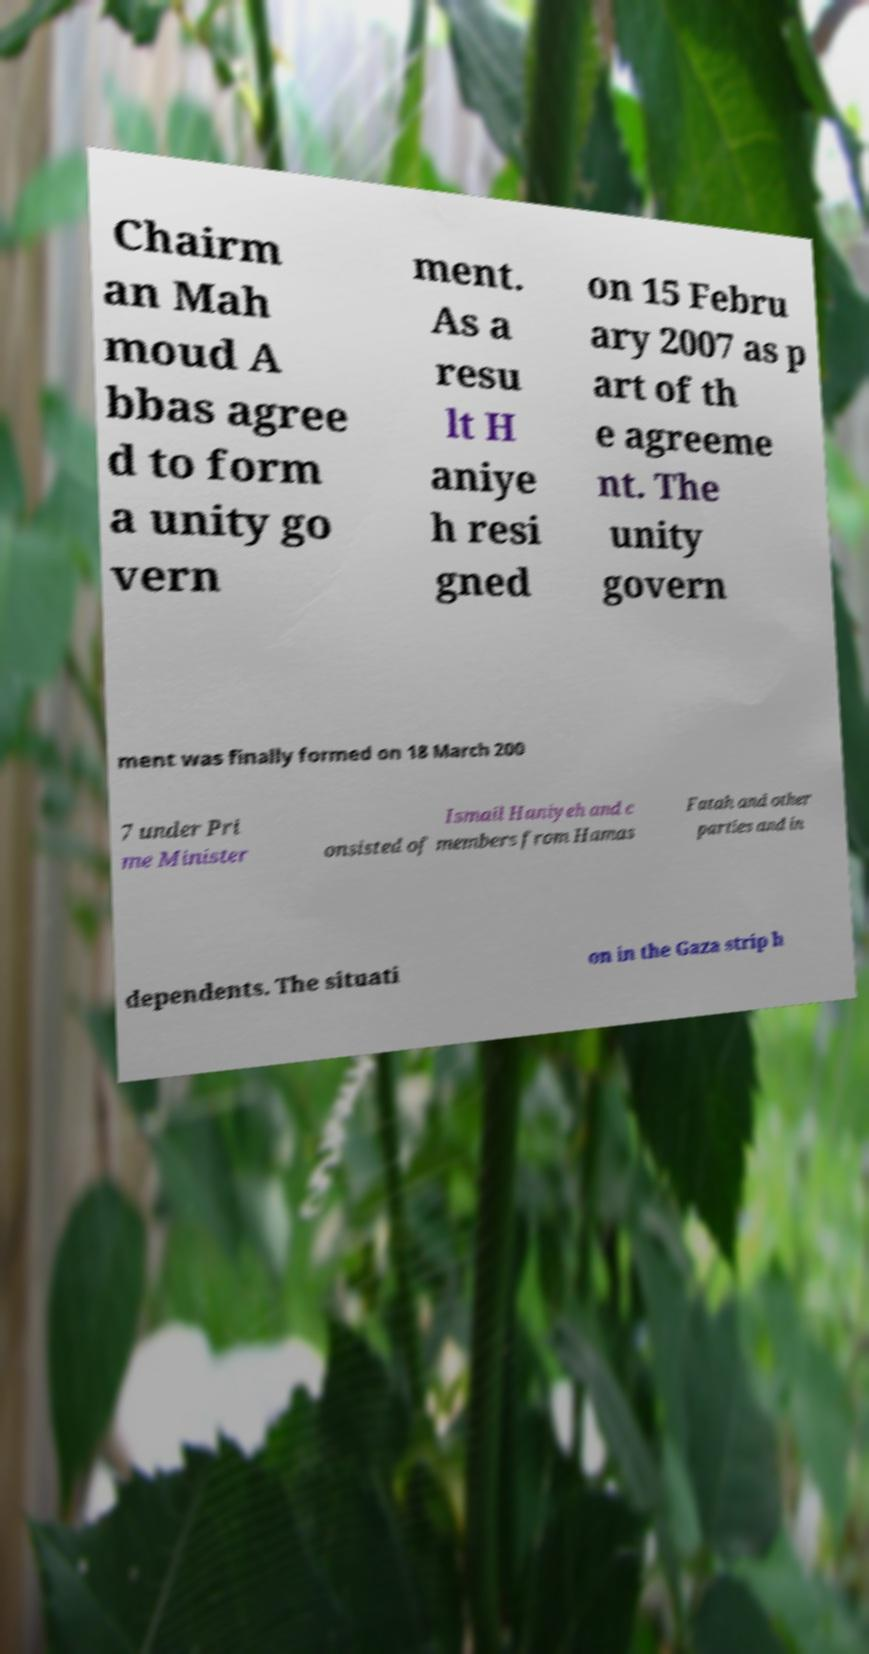Please identify and transcribe the text found in this image. Chairm an Mah moud A bbas agree d to form a unity go vern ment. As a resu lt H aniye h resi gned on 15 Febru ary 2007 as p art of th e agreeme nt. The unity govern ment was finally formed on 18 March 200 7 under Pri me Minister Ismail Haniyeh and c onsisted of members from Hamas Fatah and other parties and in dependents. The situati on in the Gaza strip h 